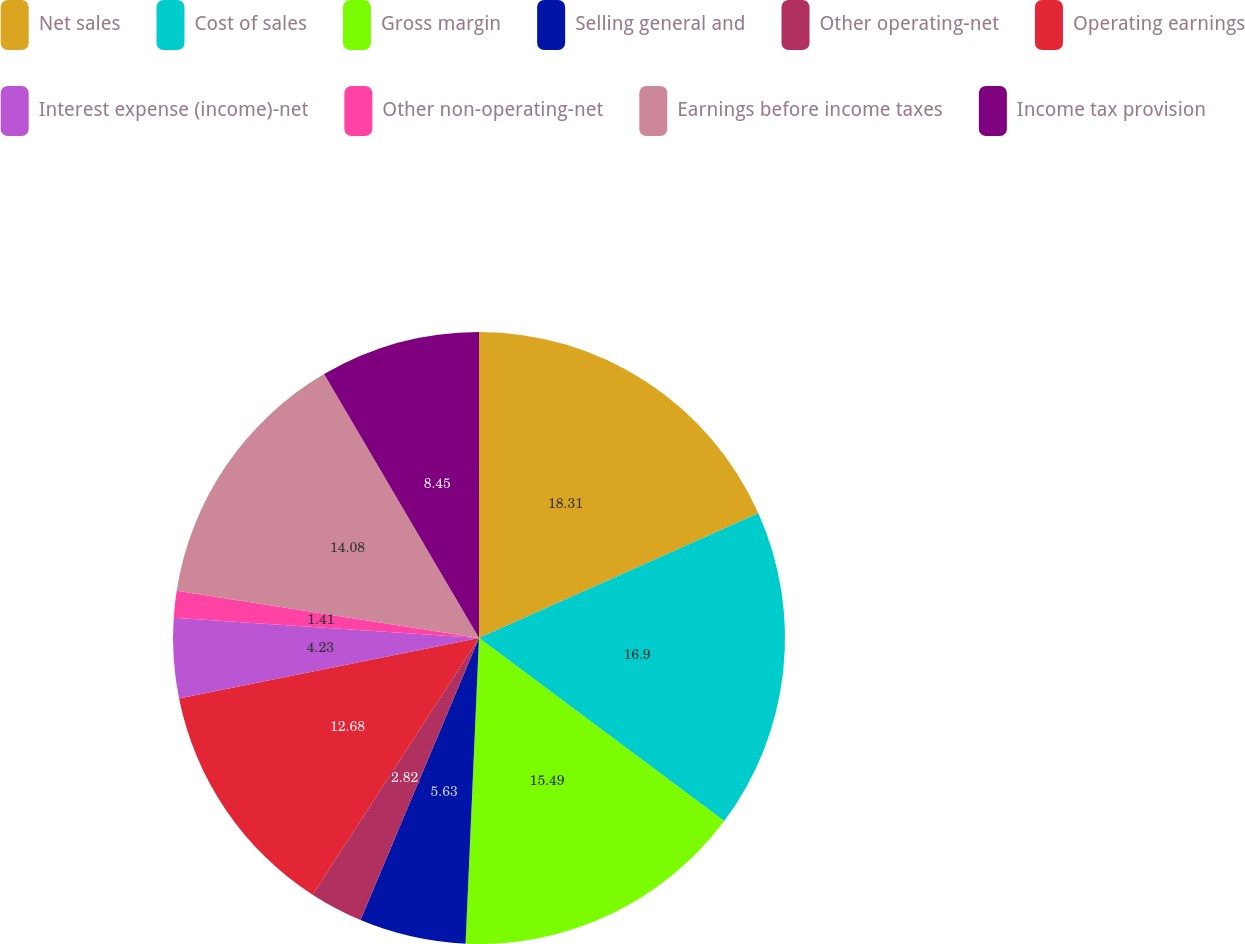Convert chart. <chart><loc_0><loc_0><loc_500><loc_500><pie_chart><fcel>Net sales<fcel>Cost of sales<fcel>Gross margin<fcel>Selling general and<fcel>Other operating-net<fcel>Operating earnings<fcel>Interest expense (income)-net<fcel>Other non-operating-net<fcel>Earnings before income taxes<fcel>Income tax provision<nl><fcel>18.31%<fcel>16.9%<fcel>15.49%<fcel>5.63%<fcel>2.82%<fcel>12.68%<fcel>4.23%<fcel>1.41%<fcel>14.08%<fcel>8.45%<nl></chart> 